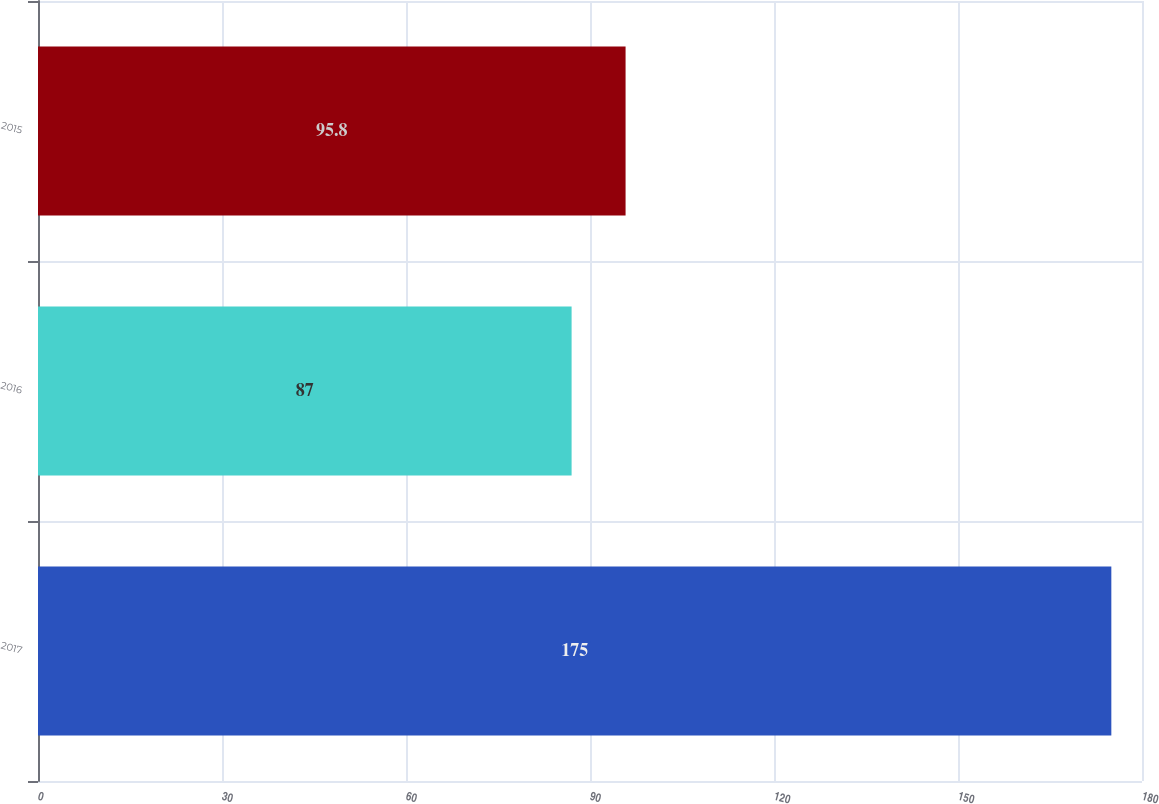<chart> <loc_0><loc_0><loc_500><loc_500><bar_chart><fcel>2017<fcel>2016<fcel>2015<nl><fcel>175<fcel>87<fcel>95.8<nl></chart> 